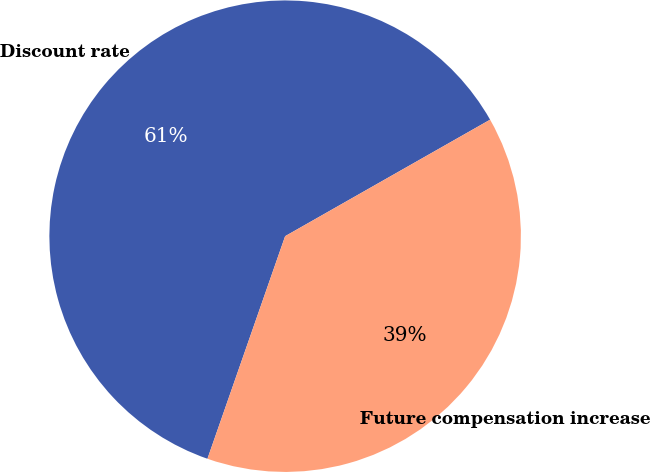Convert chart to OTSL. <chart><loc_0><loc_0><loc_500><loc_500><pie_chart><fcel>Discount rate<fcel>Future compensation increase<nl><fcel>61.43%<fcel>38.57%<nl></chart> 